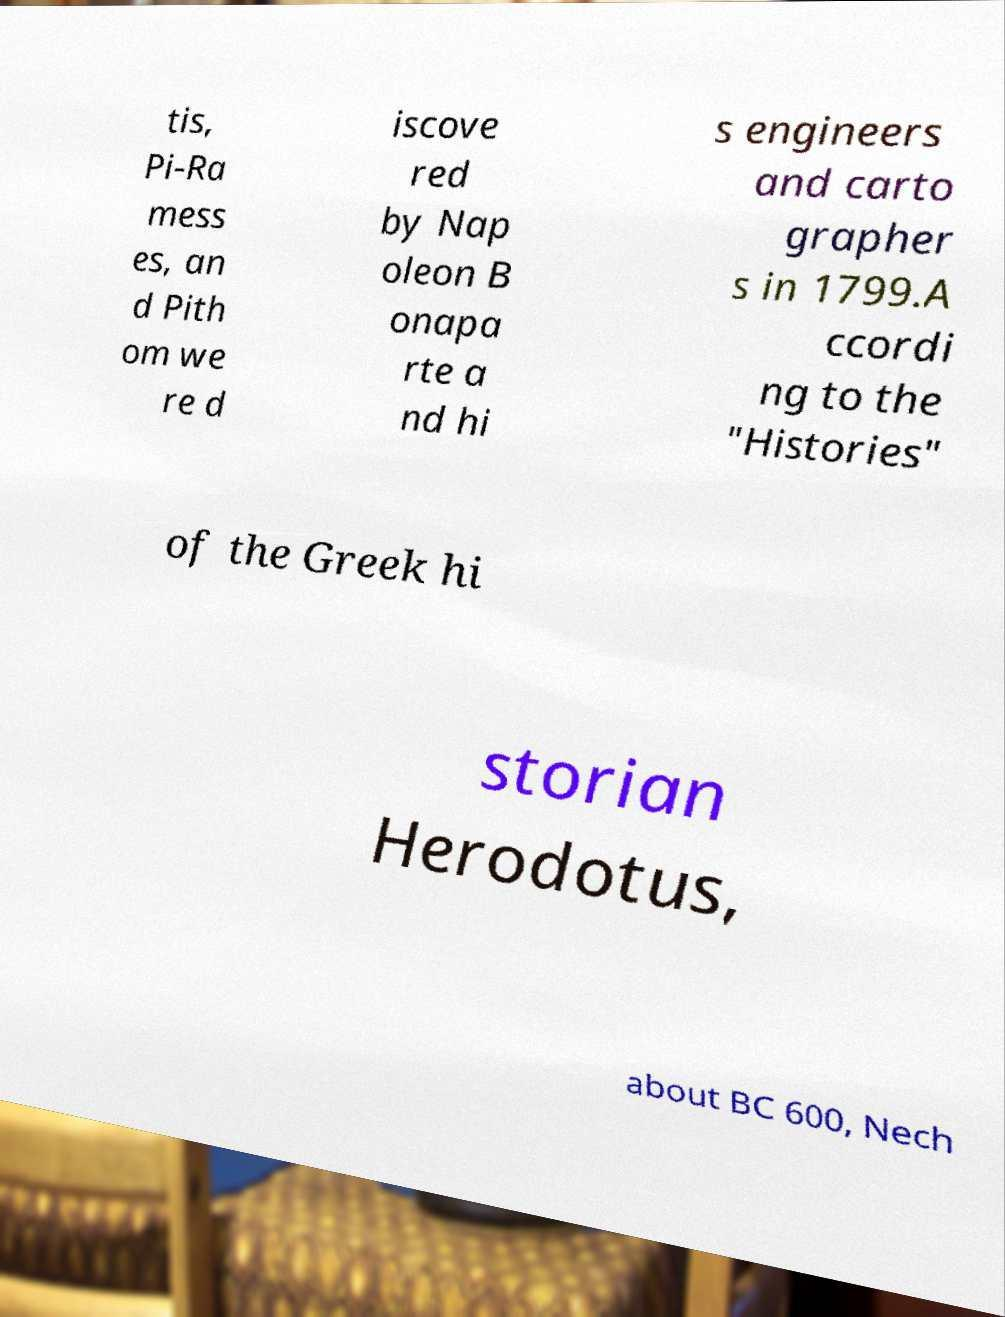Could you extract and type out the text from this image? tis, Pi-Ra mess es, an d Pith om we re d iscove red by Nap oleon B onapa rte a nd hi s engineers and carto grapher s in 1799.A ccordi ng to the "Histories" of the Greek hi storian Herodotus, about BC 600, Nech 